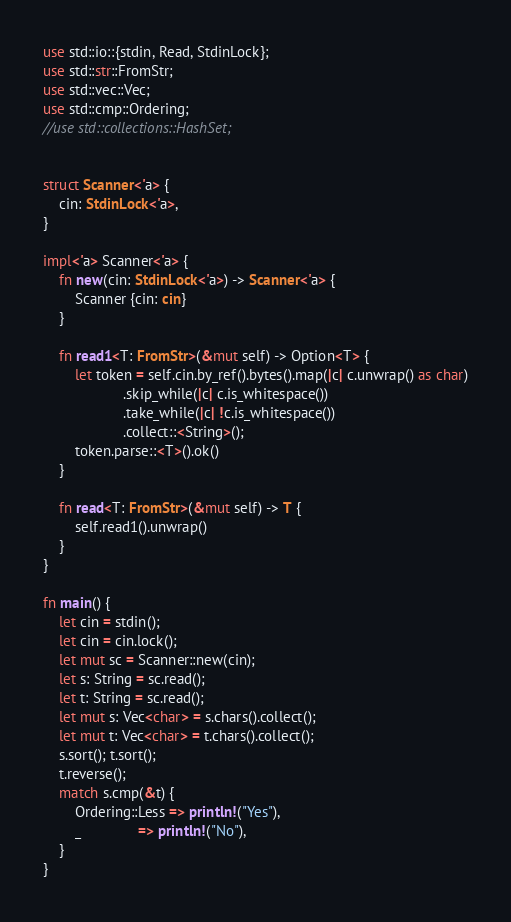Convert code to text. <code><loc_0><loc_0><loc_500><loc_500><_Rust_>use std::io::{stdin, Read, StdinLock};
use std::str::FromStr;
use std::vec::Vec;
use std::cmp::Ordering;
//use std::collections::HashSet;


struct Scanner<'a> {
    cin: StdinLock<'a>,
}

impl<'a> Scanner<'a> {
    fn new(cin: StdinLock<'a>) -> Scanner<'a> {
        Scanner {cin: cin}
    }

    fn read1<T: FromStr>(&mut self) -> Option<T> {
        let token = self.cin.by_ref().bytes().map(|c| c.unwrap() as char)
                    .skip_while(|c| c.is_whitespace())
                    .take_while(|c| !c.is_whitespace())
                    .collect::<String>();
        token.parse::<T>().ok()
    }

    fn read<T: FromStr>(&mut self) -> T {
        self.read1().unwrap()
    }
}

fn main() {
    let cin = stdin();
    let cin = cin.lock();
    let mut sc = Scanner::new(cin);
    let s: String = sc.read();
    let t: String = sc.read();
    let mut s: Vec<char> = s.chars().collect();
    let mut t: Vec<char> = t.chars().collect();
    s.sort(); t.sort();
    t.reverse();
    match s.cmp(&t) {
        Ordering::Less => println!("Yes"),
        _              => println!("No"),
    }
}</code> 